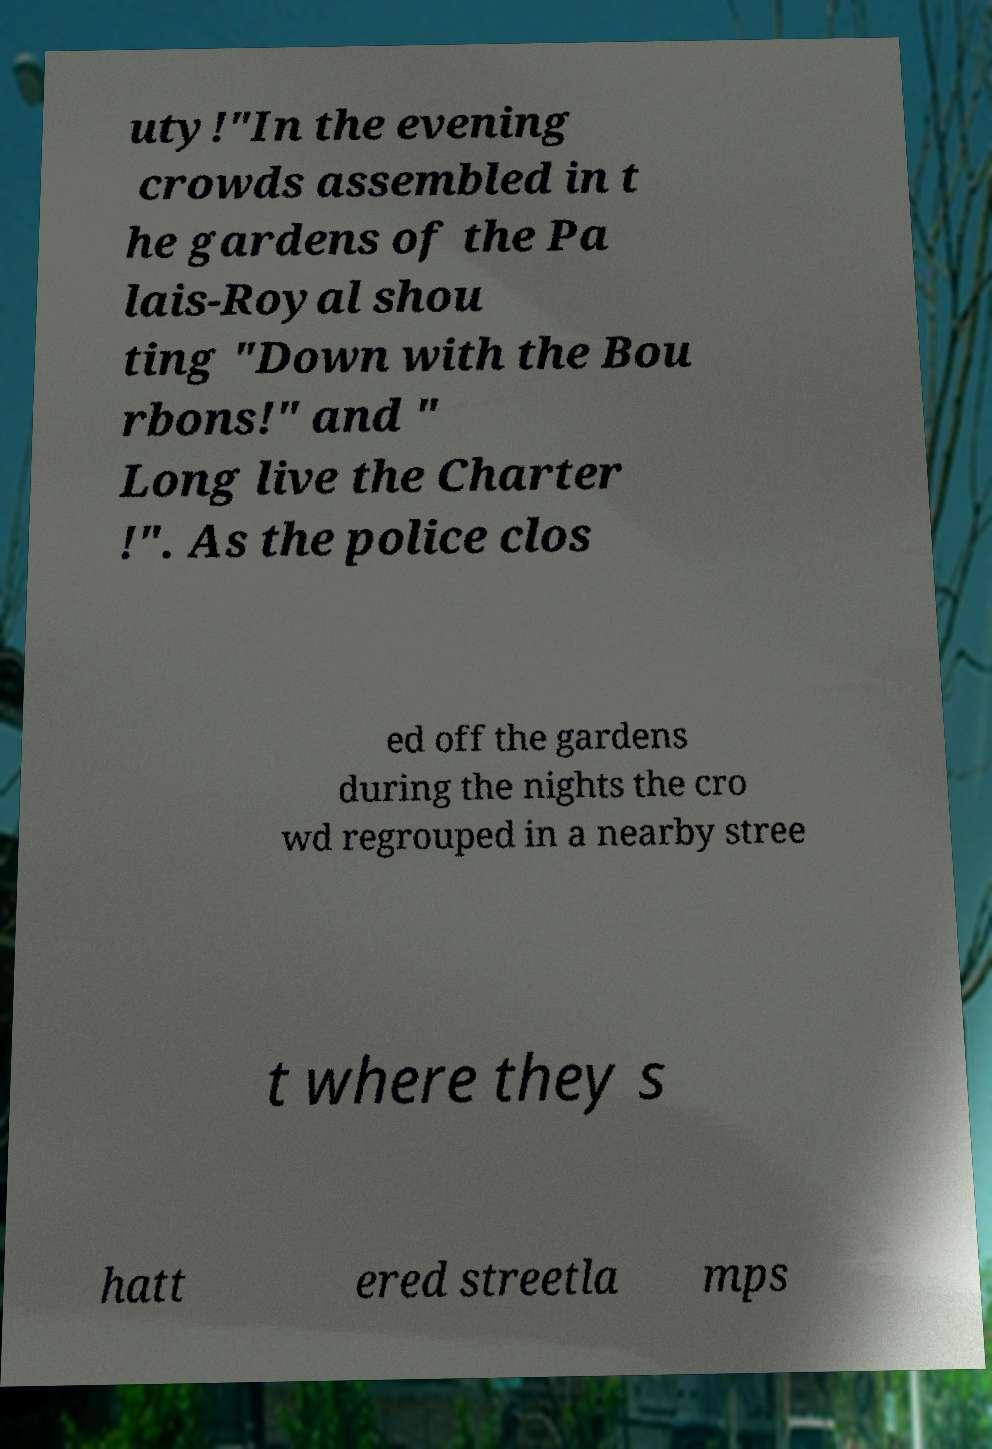I need the written content from this picture converted into text. Can you do that? uty!"In the evening crowds assembled in t he gardens of the Pa lais-Royal shou ting "Down with the Bou rbons!" and " Long live the Charter !". As the police clos ed off the gardens during the nights the cro wd regrouped in a nearby stree t where they s hatt ered streetla mps 